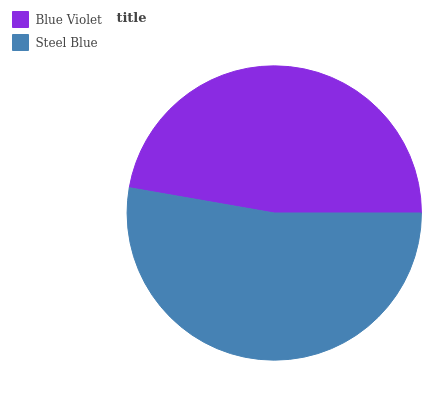Is Blue Violet the minimum?
Answer yes or no. Yes. Is Steel Blue the maximum?
Answer yes or no. Yes. Is Steel Blue the minimum?
Answer yes or no. No. Is Steel Blue greater than Blue Violet?
Answer yes or no. Yes. Is Blue Violet less than Steel Blue?
Answer yes or no. Yes. Is Blue Violet greater than Steel Blue?
Answer yes or no. No. Is Steel Blue less than Blue Violet?
Answer yes or no. No. Is Steel Blue the high median?
Answer yes or no. Yes. Is Blue Violet the low median?
Answer yes or no. Yes. Is Blue Violet the high median?
Answer yes or no. No. Is Steel Blue the low median?
Answer yes or no. No. 